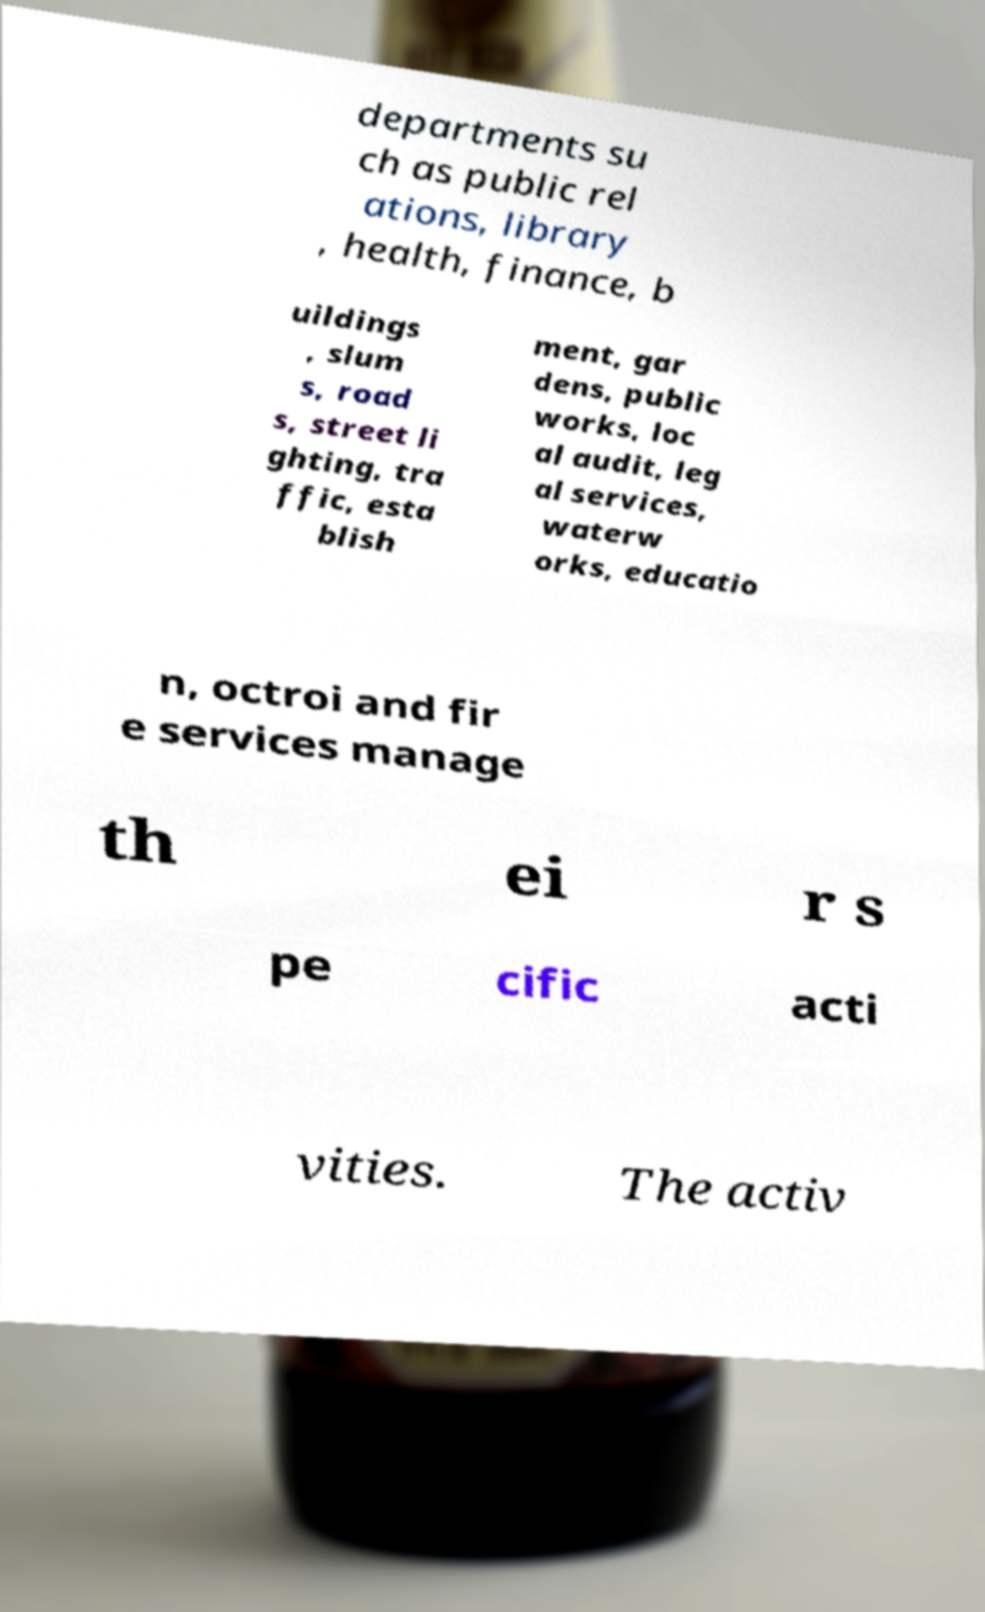What messages or text are displayed in this image? I need them in a readable, typed format. departments su ch as public rel ations, library , health, finance, b uildings , slum s, road s, street li ghting, tra ffic, esta blish ment, gar dens, public works, loc al audit, leg al services, waterw orks, educatio n, octroi and fir e services manage th ei r s pe cific acti vities. The activ 